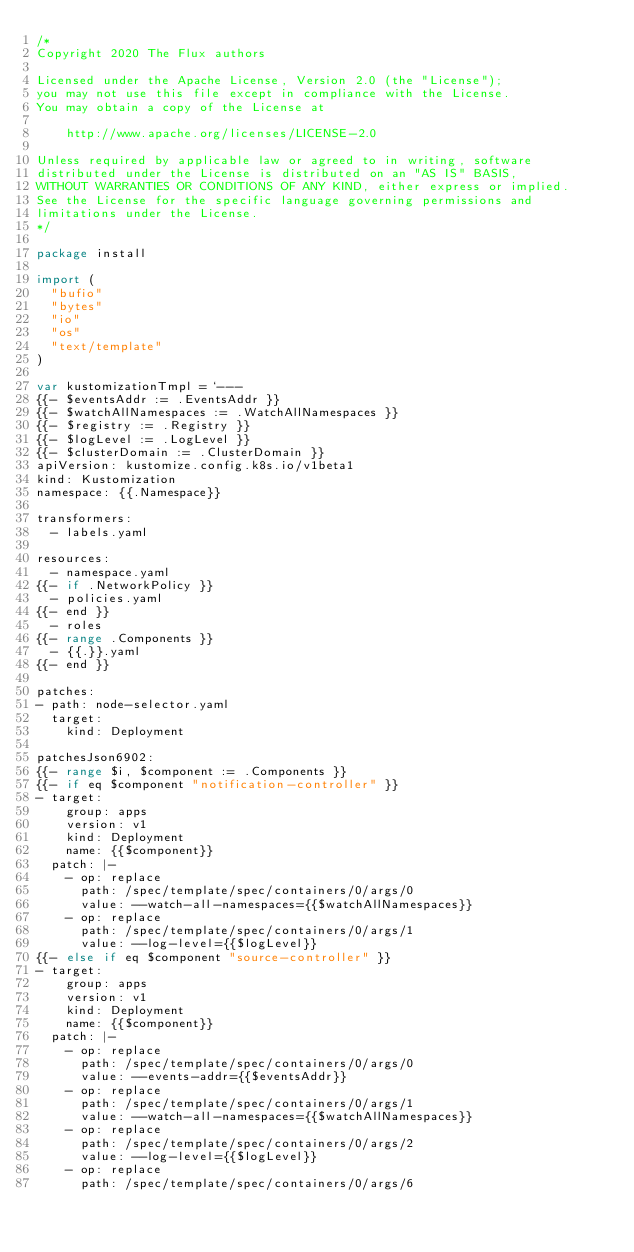Convert code to text. <code><loc_0><loc_0><loc_500><loc_500><_Go_>/*
Copyright 2020 The Flux authors

Licensed under the Apache License, Version 2.0 (the "License");
you may not use this file except in compliance with the License.
You may obtain a copy of the License at

    http://www.apache.org/licenses/LICENSE-2.0

Unless required by applicable law or agreed to in writing, software
distributed under the License is distributed on an "AS IS" BASIS,
WITHOUT WARRANTIES OR CONDITIONS OF ANY KIND, either express or implied.
See the License for the specific language governing permissions and
limitations under the License.
*/

package install

import (
	"bufio"
	"bytes"
	"io"
	"os"
	"text/template"
)

var kustomizationTmpl = `---
{{- $eventsAddr := .EventsAddr }}
{{- $watchAllNamespaces := .WatchAllNamespaces }}
{{- $registry := .Registry }}
{{- $logLevel := .LogLevel }}
{{- $clusterDomain := .ClusterDomain }}
apiVersion: kustomize.config.k8s.io/v1beta1
kind: Kustomization
namespace: {{.Namespace}}

transformers:
  - labels.yaml

resources:
  - namespace.yaml
{{- if .NetworkPolicy }}
  - policies.yaml
{{- end }}
  - roles
{{- range .Components }}
  - {{.}}.yaml
{{- end }}

patches:
- path: node-selector.yaml
  target:
    kind: Deployment

patchesJson6902:
{{- range $i, $component := .Components }}
{{- if eq $component "notification-controller" }}
- target:
    group: apps
    version: v1
    kind: Deployment
    name: {{$component}}
  patch: |-
    - op: replace
      path: /spec/template/spec/containers/0/args/0
      value: --watch-all-namespaces={{$watchAllNamespaces}}
    - op: replace
      path: /spec/template/spec/containers/0/args/1
      value: --log-level={{$logLevel}}
{{- else if eq $component "source-controller" }}
- target:
    group: apps
    version: v1
    kind: Deployment
    name: {{$component}}
  patch: |-
    - op: replace
      path: /spec/template/spec/containers/0/args/0
      value: --events-addr={{$eventsAddr}}
    - op: replace
      path: /spec/template/spec/containers/0/args/1
      value: --watch-all-namespaces={{$watchAllNamespaces}}
    - op: replace
      path: /spec/template/spec/containers/0/args/2
      value: --log-level={{$logLevel}}
    - op: replace
      path: /spec/template/spec/containers/0/args/6</code> 